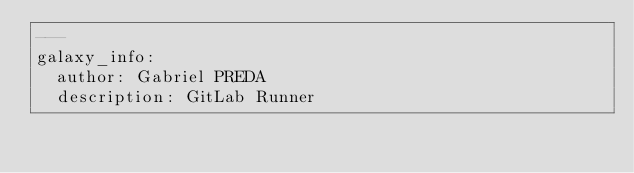<code> <loc_0><loc_0><loc_500><loc_500><_YAML_>---
galaxy_info:
  author: Gabriel PREDA
  description: GitLab Runner</code> 